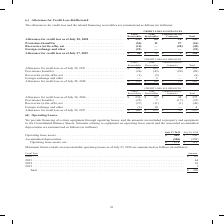According to Cisco Systems's financial document, What was the allowance for credit loss for lease receivables in 2018? According to the financial document, 135 (in millions). The relevant text states: "2018 � � � � � � � � � � � � � � � � � � � � � $ 135 $ 60 $ 10 $ 205 Provisions (benefits) � � � � � � � � � � � � � � � � � � � � � � � � � � � � � � �..." Also, What were the total provisions (benefits)? According to the financial document, (16) (in millions). The relevant text states: "� � � � � � � � � � � � � � � � � � � � (54) 11 27 (16) Recoveries (write-offs), net � � � � � � � � � � � � � � � � � � � � � � � � � � � � � � � � � � � (..." Also, What were the total Foreign exchange and other? According to the financial document, (21) (in millions). The relevant text states: "� � � � � � � � � � � � � � � � � � � � � � � � � (21) — — (21) Allowance for credit loss as of July 27, 2019 � � � � � � � � � � � � � � � � � � � � � $ 4..." Also, can you calculate: What was the difference between total provisions (benefits) and net recoveries (write-offs)? Based on the calculation: -16-(-42), the result is 26 (in millions). This is based on the information: "� � � � � � � � � � � � � � � � � � � (54) 11 27 (16) Recoveries (write-offs), net � � � � � � � � � � � � � � � � � � � � � � � � � � � � � � � � � � � � � � � � � � � � � � � � � � � � � (14) — (28)..." The key data points involved are: 16, 42. Also, can you calculate: What was the allowance for credit loss for financed service contracts as a percentage of total allowance for credit loss in 2018? Based on the calculation: 10/205, the result is 4.88 (percentage). This is based on the information: "� � � � � � � � � � � � � � � � $ 135 $ 60 $ 10 $ 205 Provisions (benefits) � � � � � � � � � � � � � � � � � � � � � � � � � � � � � � � � � � � � � � � � � � � � � � � � � � � � � � � � � $ 135 $ 60..." The key data points involved are: 10, 205. Also, can you calculate: What was the percentage change in the total allowance for credit loss between 2018 and 2019? To answer this question, I need to perform calculations using the financial data. The calculation is: (126-205)/205, which equals -38.54 (percentage). This is based on the information: "� � � � � � � � � � � � � � � � $ 135 $ 60 $ 10 $ 205 Provisions (benefits) � � � � � � � � � � � � � � � � � � � � � � � � � � � � � � � � � � � � � � � � � � � � � � � � � � � � � � � � $ 46 $ 71 $ ..." The key data points involved are: 126, 205. 